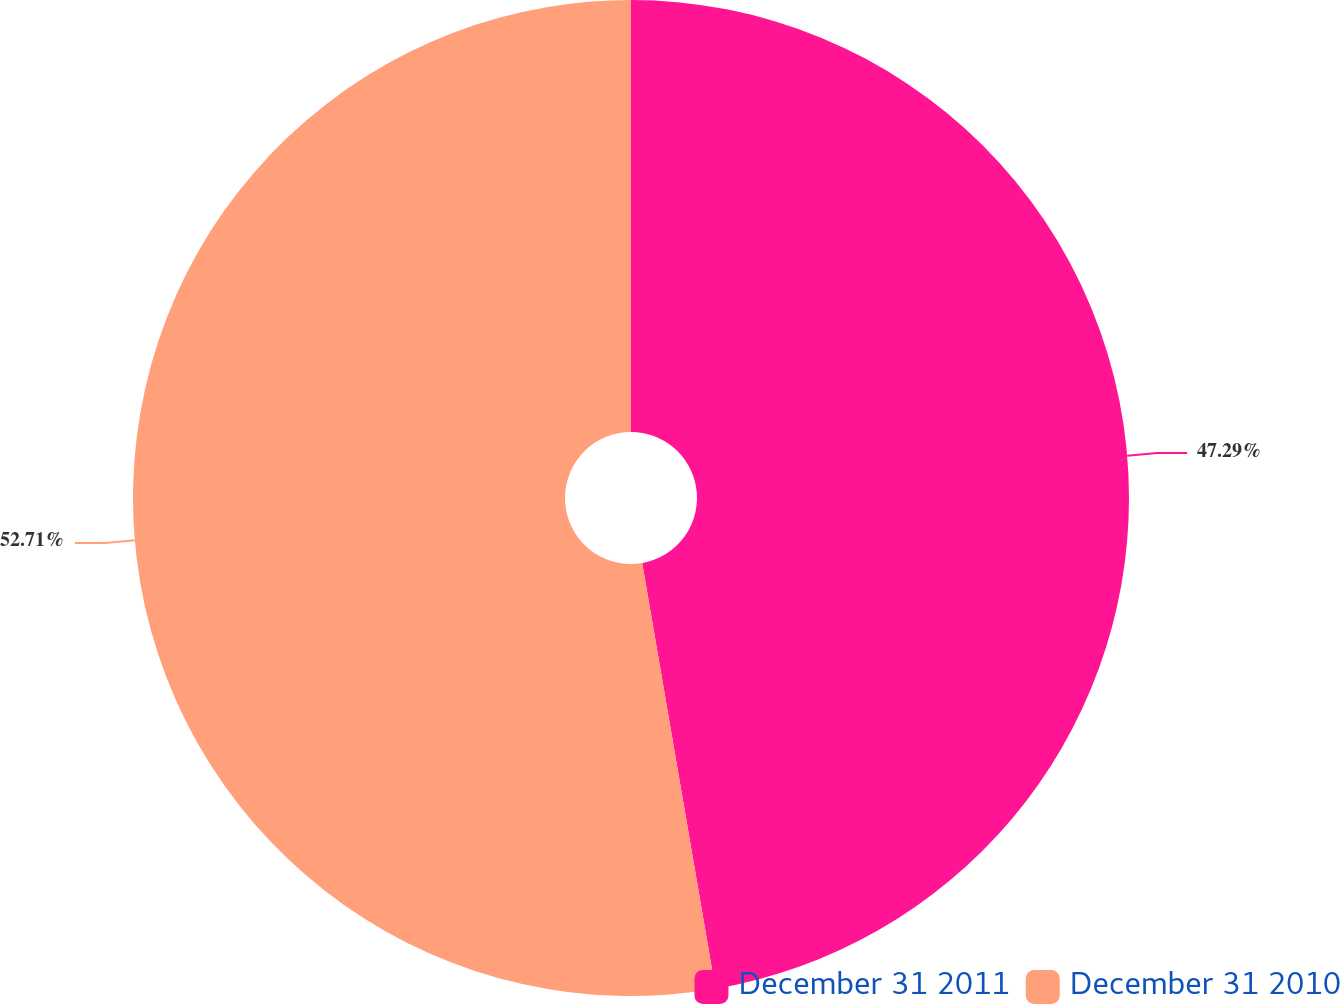Convert chart. <chart><loc_0><loc_0><loc_500><loc_500><pie_chart><fcel>December 31 2011<fcel>December 31 2010<nl><fcel>47.29%<fcel>52.71%<nl></chart> 